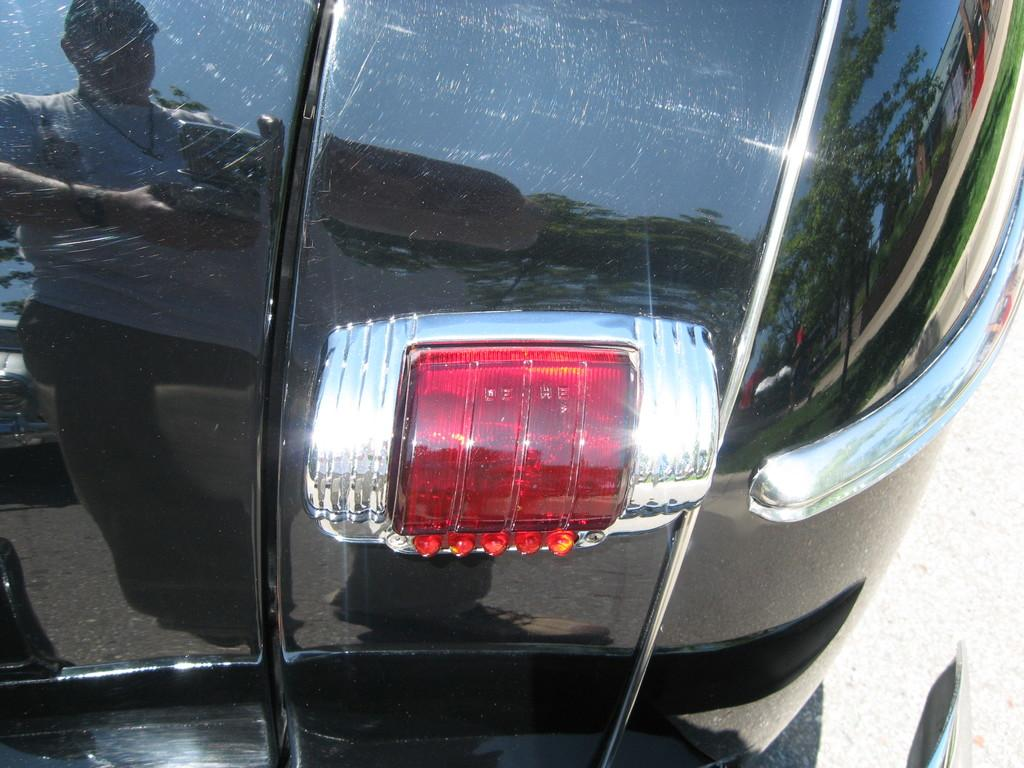What is on the road in the image? There is a vehicle on the road in the image. What can be seen on the vehicle's surface? There is a reflection of a man and trees on the vehicle. What type of meat is being cooked in the image? There is no meat or cooking activity present in the image; it features a vehicle with reflections on its surface. 